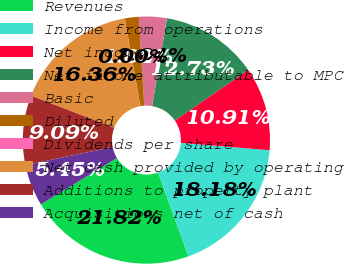Convert chart. <chart><loc_0><loc_0><loc_500><loc_500><pie_chart><fcel>Revenues<fcel>Income from operations<fcel>Net income<fcel>Net income attributable to MPC<fcel>Basic<fcel>Diluted<fcel>Dividends per share<fcel>Net cash provided by operating<fcel>Additions to property plant<fcel>Acquisitions net of cash<nl><fcel>21.82%<fcel>18.18%<fcel>10.91%<fcel>12.73%<fcel>3.64%<fcel>1.82%<fcel>0.0%<fcel>16.36%<fcel>9.09%<fcel>5.45%<nl></chart> 